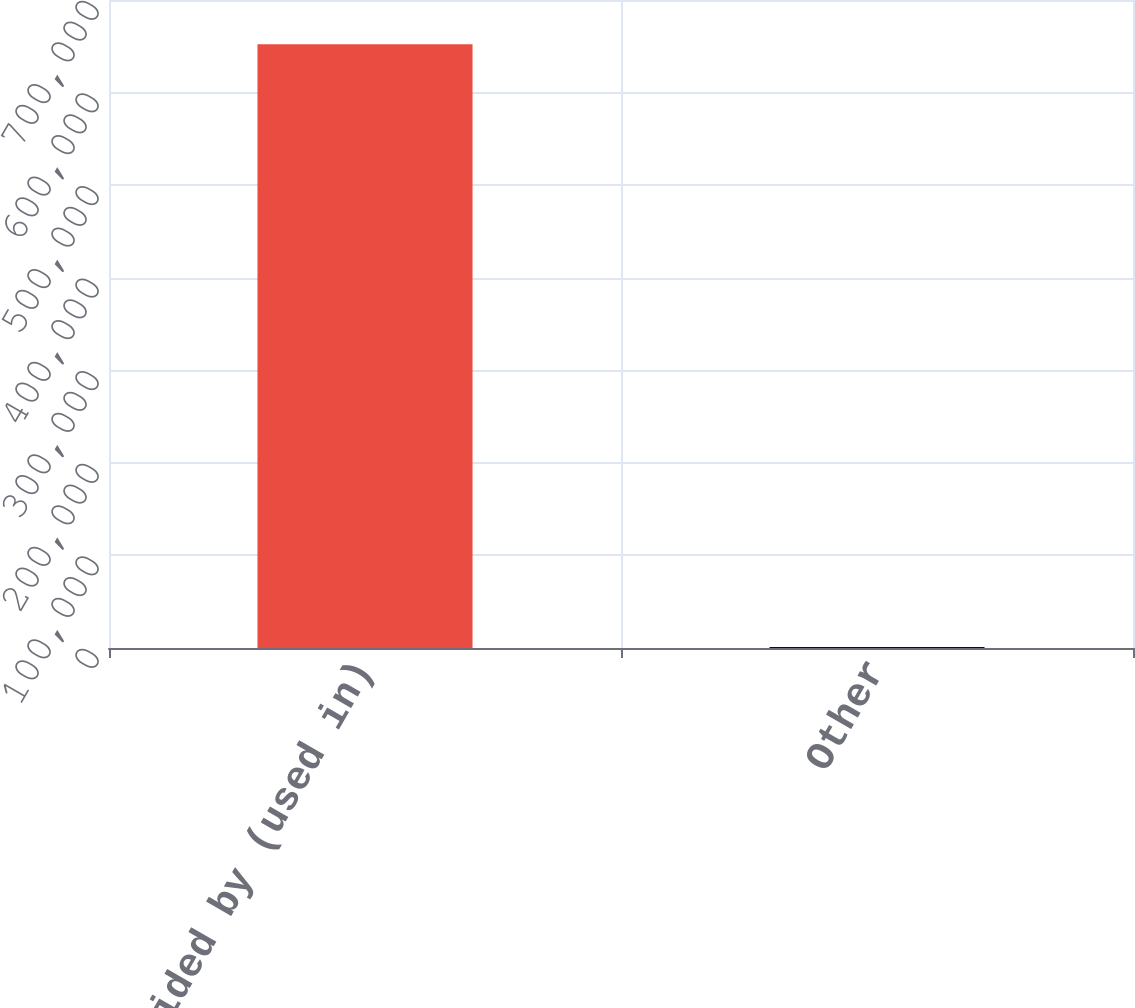Convert chart. <chart><loc_0><loc_0><loc_500><loc_500><bar_chart><fcel>Net cash provided by (used in)<fcel>Other<nl><fcel>652330<fcel>1148<nl></chart> 